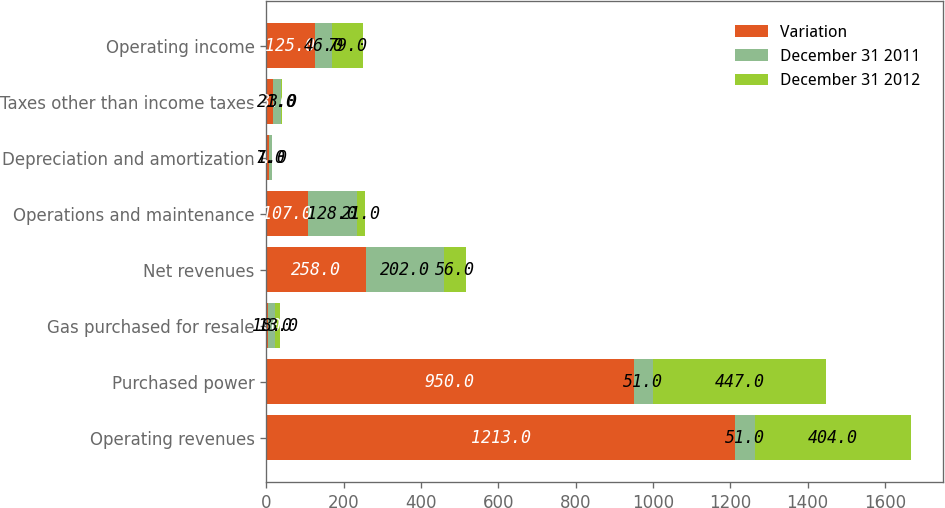<chart> <loc_0><loc_0><loc_500><loc_500><stacked_bar_chart><ecel><fcel>Operating revenues<fcel>Purchased power<fcel>Gas purchased for resale<fcel>Net revenues<fcel>Operations and maintenance<fcel>Depreciation and amortization<fcel>Taxes other than income taxes<fcel>Operating income<nl><fcel>Variation<fcel>1213<fcel>950<fcel>5<fcel>258<fcel>107<fcel>8<fcel>18<fcel>125<nl><fcel>December 31 2011<fcel>51<fcel>51<fcel>18<fcel>202<fcel>128<fcel>7<fcel>21<fcel>46<nl><fcel>December 31 2012<fcel>404<fcel>447<fcel>13<fcel>56<fcel>21<fcel>1<fcel>3<fcel>79<nl></chart> 